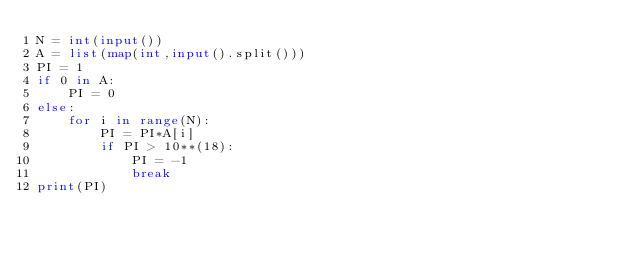<code> <loc_0><loc_0><loc_500><loc_500><_Python_>N = int(input())
A = list(map(int,input().split()))
PI = 1
if 0 in A:
    PI = 0
else:
    for i in range(N):
        PI = PI*A[i]
        if PI > 10**(18):
            PI = -1
            break
print(PI)
</code> 